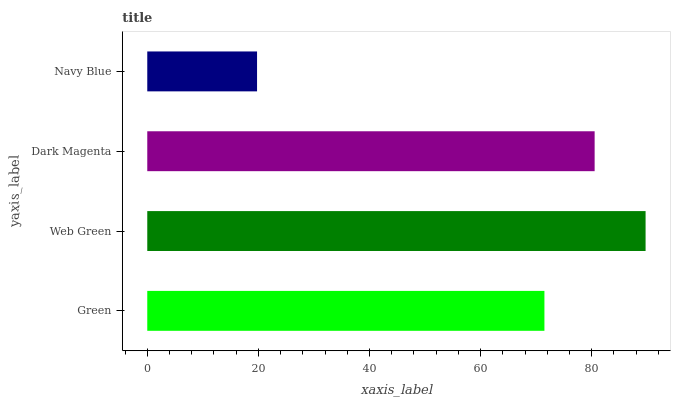Is Navy Blue the minimum?
Answer yes or no. Yes. Is Web Green the maximum?
Answer yes or no. Yes. Is Dark Magenta the minimum?
Answer yes or no. No. Is Dark Magenta the maximum?
Answer yes or no. No. Is Web Green greater than Dark Magenta?
Answer yes or no. Yes. Is Dark Magenta less than Web Green?
Answer yes or no. Yes. Is Dark Magenta greater than Web Green?
Answer yes or no. No. Is Web Green less than Dark Magenta?
Answer yes or no. No. Is Dark Magenta the high median?
Answer yes or no. Yes. Is Green the low median?
Answer yes or no. Yes. Is Navy Blue the high median?
Answer yes or no. No. Is Web Green the low median?
Answer yes or no. No. 